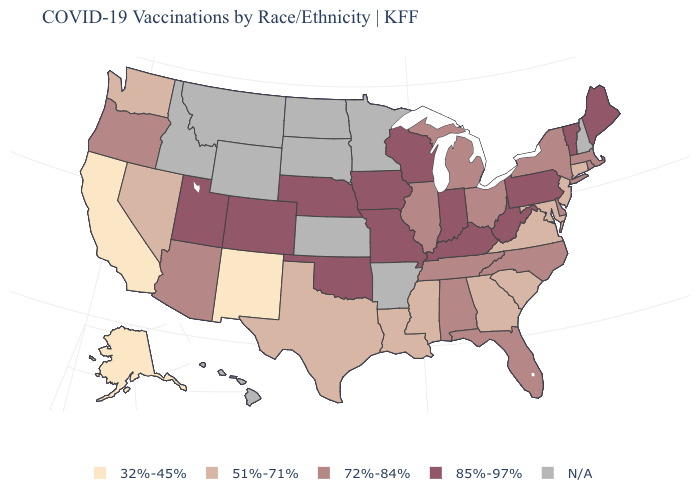How many symbols are there in the legend?
Concise answer only. 5. What is the value of Oklahoma?
Concise answer only. 85%-97%. Name the states that have a value in the range 32%-45%?
Short answer required. Alaska, California, New Mexico. Does the first symbol in the legend represent the smallest category?
Quick response, please. Yes. Which states have the lowest value in the West?
Short answer required. Alaska, California, New Mexico. What is the value of Arkansas?
Quick response, please. N/A. Does Virginia have the highest value in the USA?
Concise answer only. No. Does Texas have the lowest value in the USA?
Short answer required. No. Which states have the lowest value in the USA?
Short answer required. Alaska, California, New Mexico. Does the first symbol in the legend represent the smallest category?
Short answer required. Yes. What is the lowest value in the USA?
Give a very brief answer. 32%-45%. What is the value of Arkansas?
Keep it brief. N/A. Does the map have missing data?
Give a very brief answer. Yes. What is the highest value in the South ?
Short answer required. 85%-97%. 